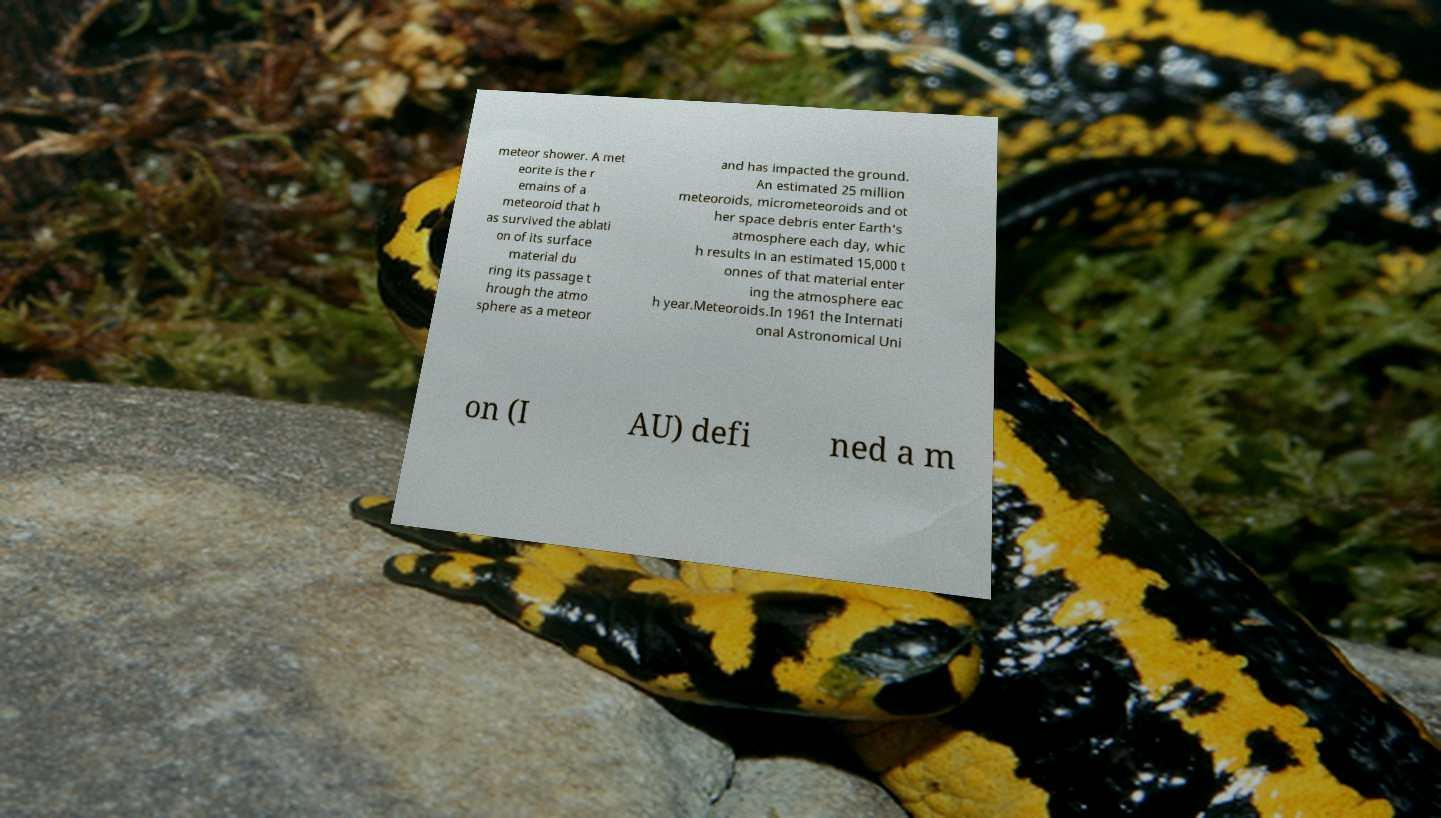What messages or text are displayed in this image? I need them in a readable, typed format. meteor shower. A met eorite is the r emains of a meteoroid that h as survived the ablati on of its surface material du ring its passage t hrough the atmo sphere as a meteor and has impacted the ground. An estimated 25 million meteoroids, micrometeoroids and ot her space debris enter Earth's atmosphere each day, whic h results in an estimated 15,000 t onnes of that material enter ing the atmosphere eac h year.Meteoroids.In 1961 the Internati onal Astronomical Uni on (I AU) defi ned a m 